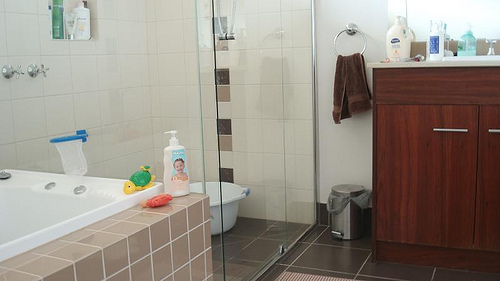Can you narrate a short story happening in this bathroom? In this serene bathroom, little Timmy is having a fun evening bath. His toys, including his favorite turtle toy, are scattered around the tub. His mom, standing nearby, is singing a gentle lullaby while organizing the toiletries on the counter. The soothing sound of water splashing and the warmth envelop Timmy as he laughs and plays, creating a heartwarming and peaceful evening routine. 